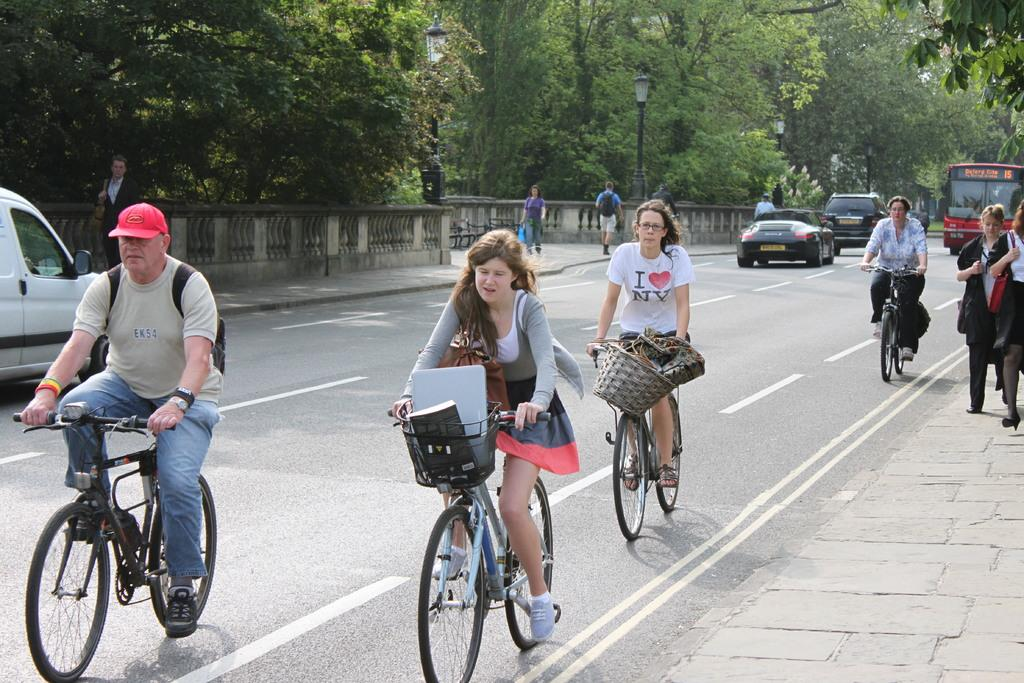How many people are in the image? There are four people in the image. What are the people doing in the image? The people are riding bicycles. Where are the bicycles located? The bicycles are on a road. What can be seen on the left side of the image? There are trees on the left side of the image. What is the weight of the bicycles in the image? The weight of the bicycles cannot be determined from the image alone. 